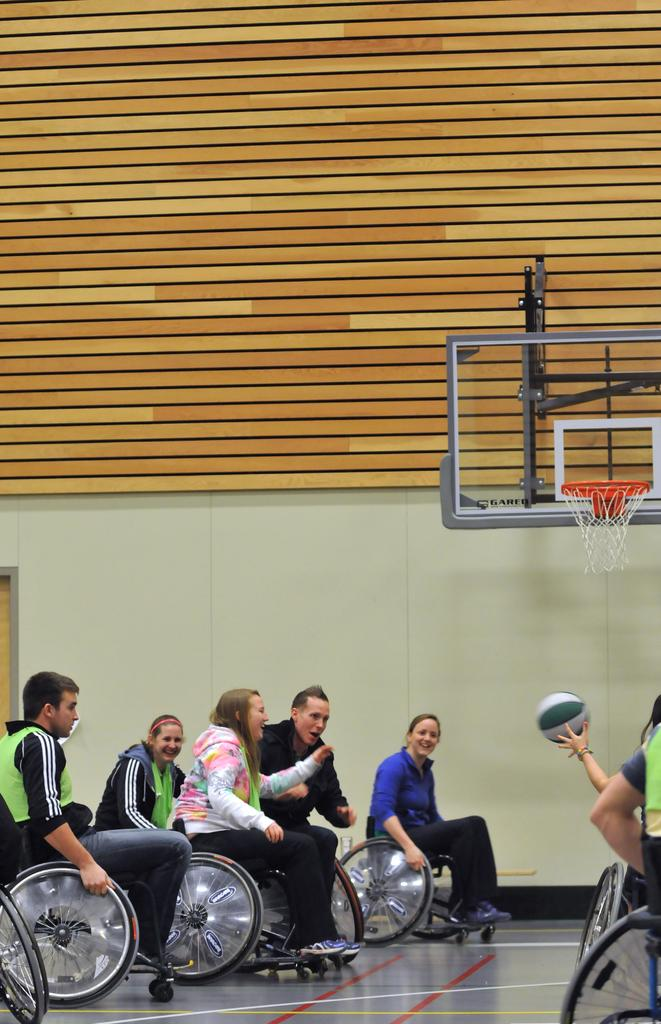What are the people in the image doing? The people are playing basketball. What type of chairs are the people sitting on? The people are sitting on wheelchairs. What is the main feature of the basketball court in the image? There is a basketball ring in the image. What type of liquid can be seen spilling from the pin in the image? There is no liquid or pin present in the image; it features people playing basketball while sitting on wheelchairs. 